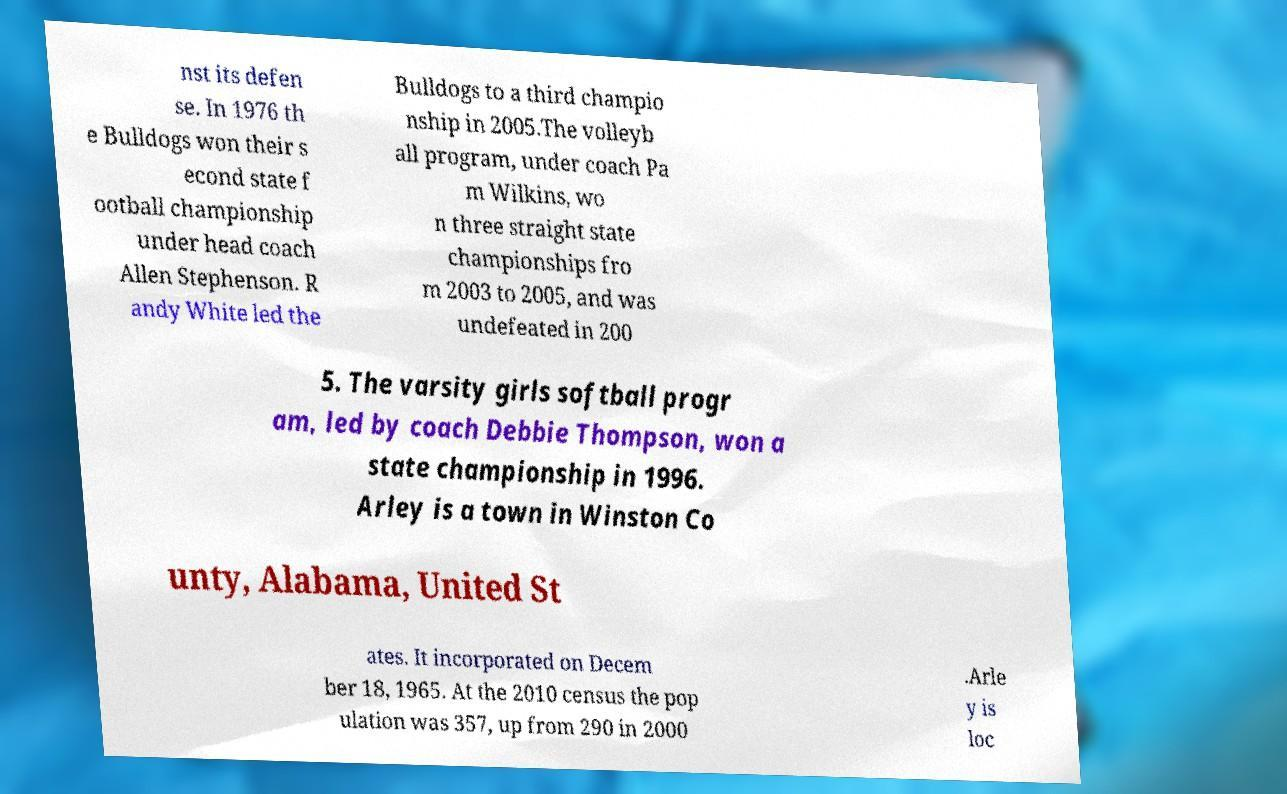I need the written content from this picture converted into text. Can you do that? nst its defen se. In 1976 th e Bulldogs won their s econd state f ootball championship under head coach Allen Stephenson. R andy White led the Bulldogs to a third champio nship in 2005.The volleyb all program, under coach Pa m Wilkins, wo n three straight state championships fro m 2003 to 2005, and was undefeated in 200 5. The varsity girls softball progr am, led by coach Debbie Thompson, won a state championship in 1996. Arley is a town in Winston Co unty, Alabama, United St ates. It incorporated on Decem ber 18, 1965. At the 2010 census the pop ulation was 357, up from 290 in 2000 .Arle y is loc 